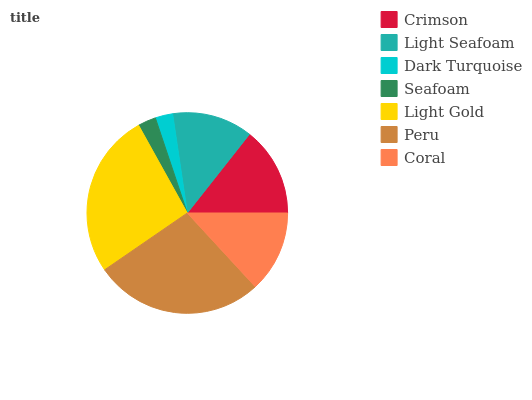Is Dark Turquoise the minimum?
Answer yes or no. Yes. Is Peru the maximum?
Answer yes or no. Yes. Is Light Seafoam the minimum?
Answer yes or no. No. Is Light Seafoam the maximum?
Answer yes or no. No. Is Crimson greater than Light Seafoam?
Answer yes or no. Yes. Is Light Seafoam less than Crimson?
Answer yes or no. Yes. Is Light Seafoam greater than Crimson?
Answer yes or no. No. Is Crimson less than Light Seafoam?
Answer yes or no. No. Is Coral the high median?
Answer yes or no. Yes. Is Coral the low median?
Answer yes or no. Yes. Is Seafoam the high median?
Answer yes or no. No. Is Peru the low median?
Answer yes or no. No. 